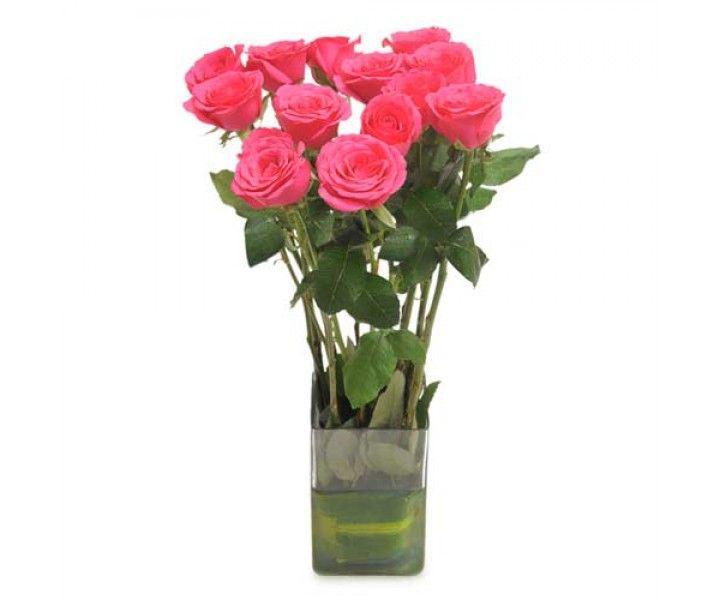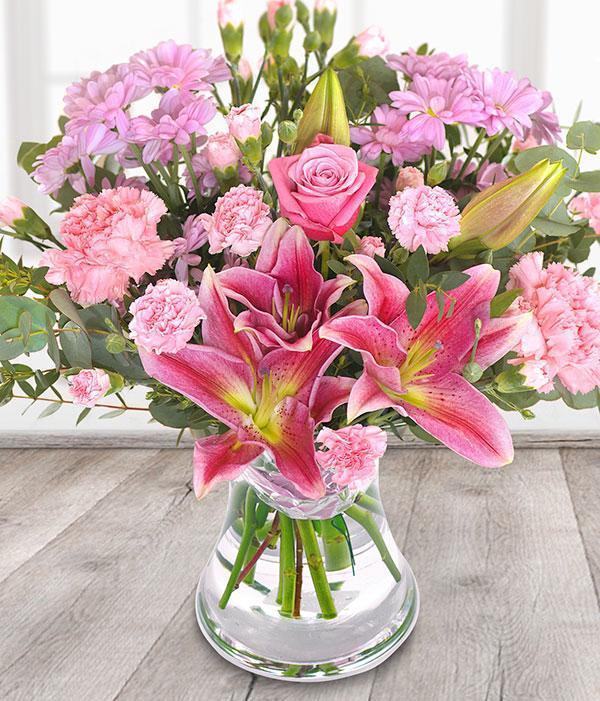The first image is the image on the left, the second image is the image on the right. Analyze the images presented: Is the assertion "There are at least nine roses in the image on the left." valid? Answer yes or no. Yes. 